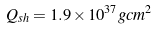Convert formula to latex. <formula><loc_0><loc_0><loc_500><loc_500>Q _ { s h } = 1 . 9 \times 1 0 ^ { 3 7 } g c m ^ { 2 }</formula> 